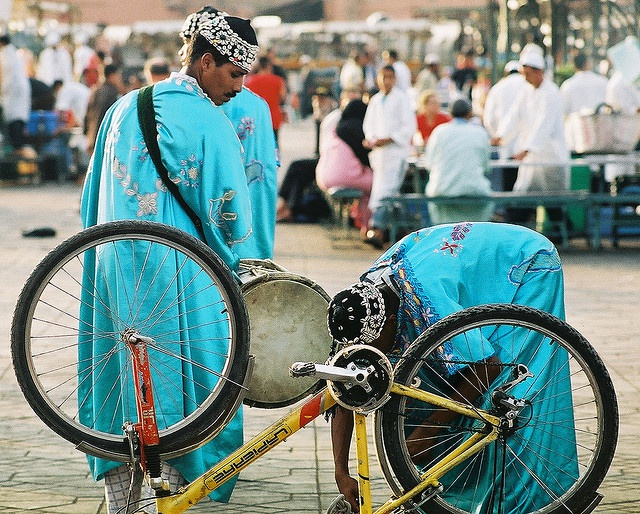Describe the objects in this image and their specific colors. I can see bicycle in lightgray, black, and teal tones, people in lightgray, lightblue, and teal tones, people in lightgray, black, lightblue, and teal tones, people in lightgray, black, darkgray, and gray tones, and people in lightgray, lightblue, darkgray, and teal tones in this image. 